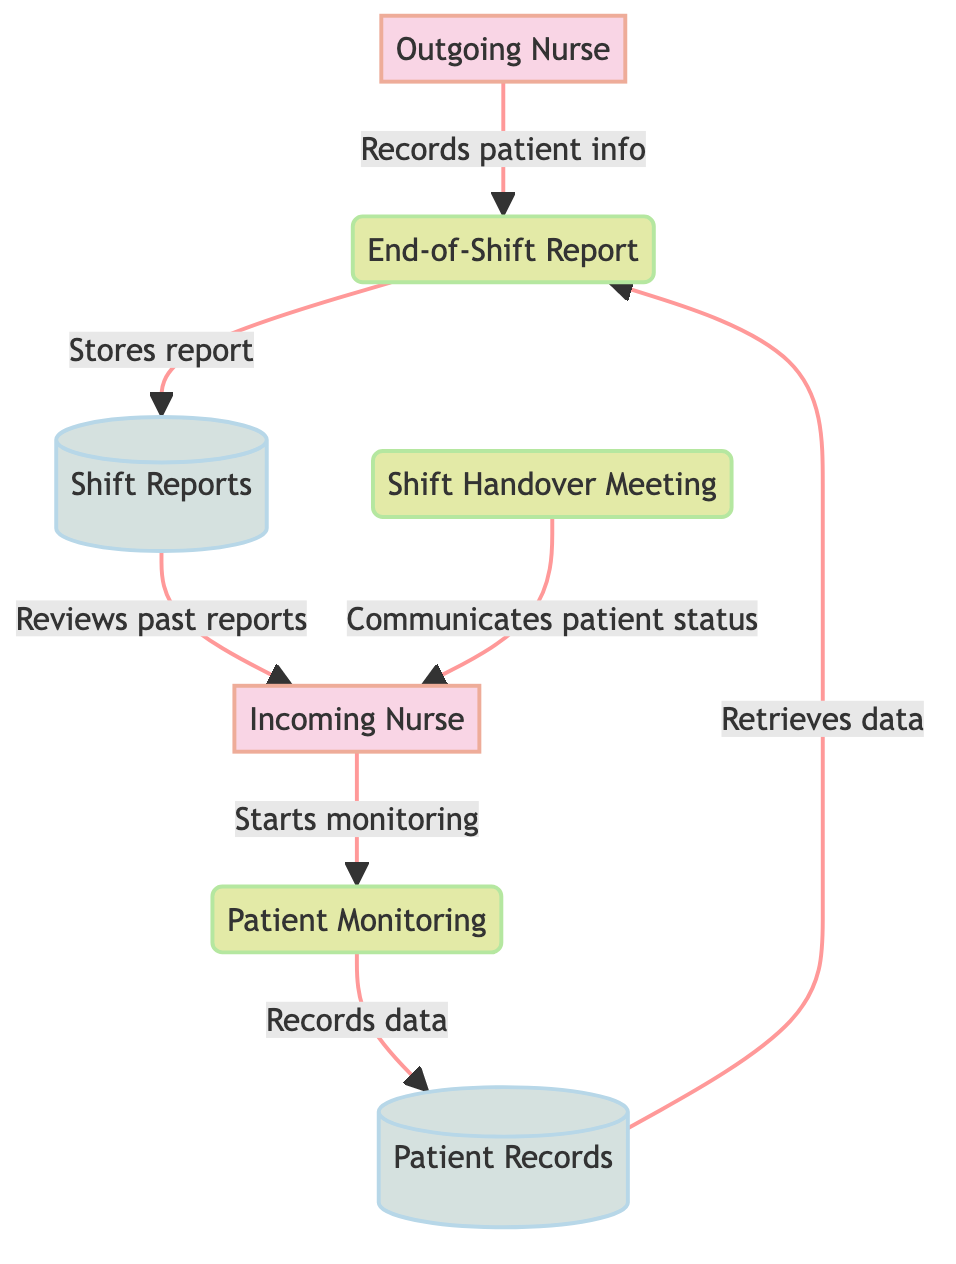What is the main purpose of the "End-of-Shift Report"? The "End-of-Shift Report" serves to summarize patient care during the outgoing nurse's shift, capturing important details that need to be communicated to the incoming nurse.
Answer: Summarize patient care How many external entities are present in the diagram? The diagram contains two external entities: the Outgoing Nurse and the Incoming Nurse.
Answer: Two Who receives the "Shift Handover Meeting" information? The information from the "Shift Handover Meeting" is provided to the Incoming Nurse, who is responsible for taking over patient care.
Answer: Incoming Nurse What is stored in the "Shift Reports"? The "Shift Reports" store completed end-of-shift reports that contain details necessary for future reference regarding patient care over different shifts.
Answer: Completed end-of-shift reports What process follows the "End-of-Shift Report"? After the "End-of-Shift Report," the process that follows is the "Shift Handover Meeting," where the outgoing nurse communicates critical patient information to the incoming nurse.
Answer: Shift Handover Meeting Which data store does the "Patient Monitoring" process send data to? The "Patient Monitoring" process sends ongoing patient data to the "Patient Records" data store, maintaining up-to-date medical information.
Answer: Patient Records What does the "Incoming Nurse" do after the "Shift Handover Meeting"? After the "Shift Handover Meeting," the Incoming Nurse begins monitoring and caring for patients, engaging in direct patient care activities.
Answer: Start monitoring and caring How is patient information updated in the "End-of-Shift Report"? Patient information in the "End-of-Shift Report" is updated by retrieving data from the "Patient Records" database to ensure the report is accurate and comprehensive at the end of the shift.
Answer: By retrieving data What type of diagram is this? The diagram is a Data Flow Diagram, which illustrates how data flows through various processes, data stores, and external entities involved in the daily nurse shift handover.
Answer: Data Flow Diagram 